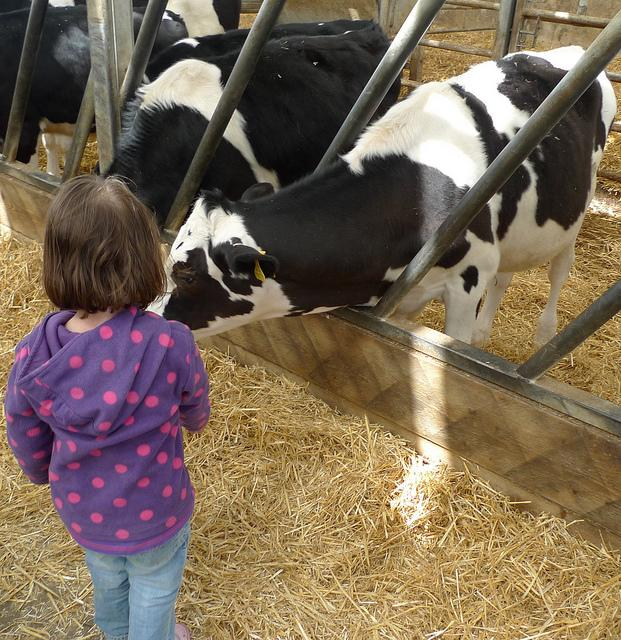What is near the cows? Please explain your reasoning. little girl. A female person is near the cows. she is not an adult. 